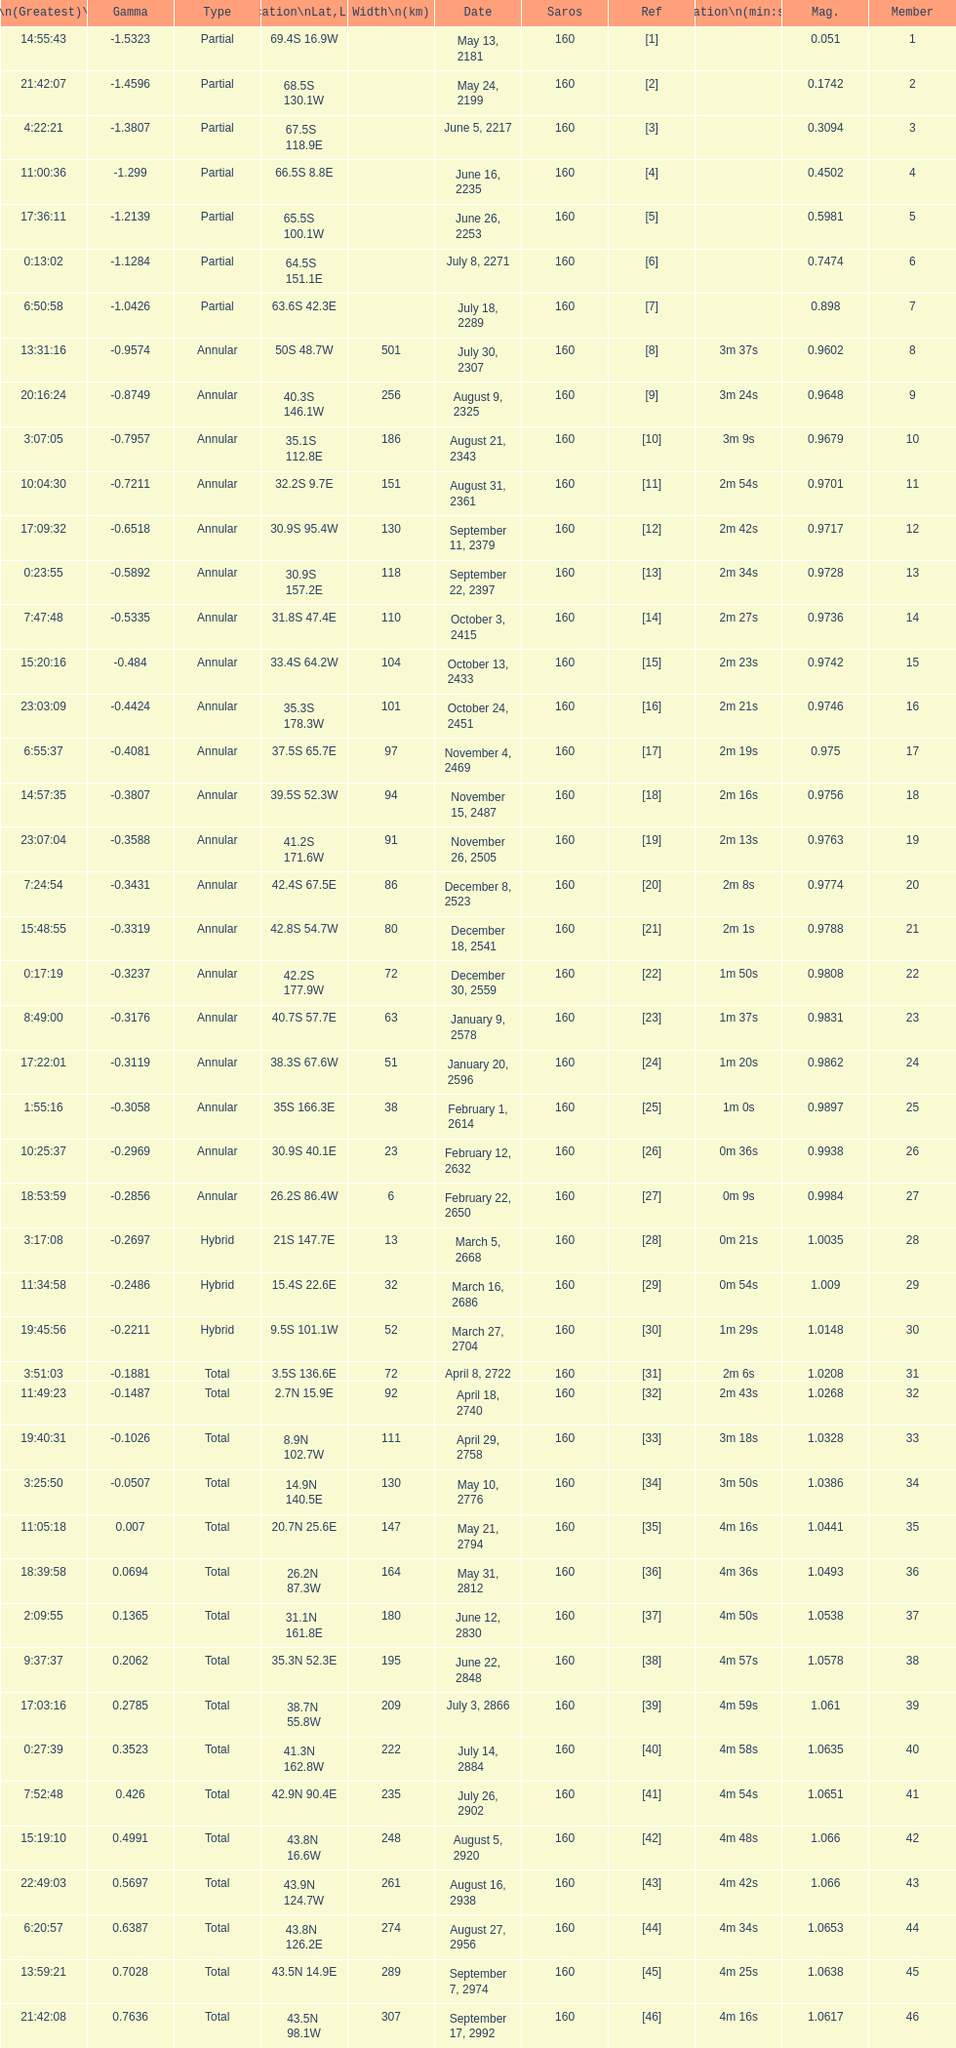How many partial members will occur before the first annular? 7. 